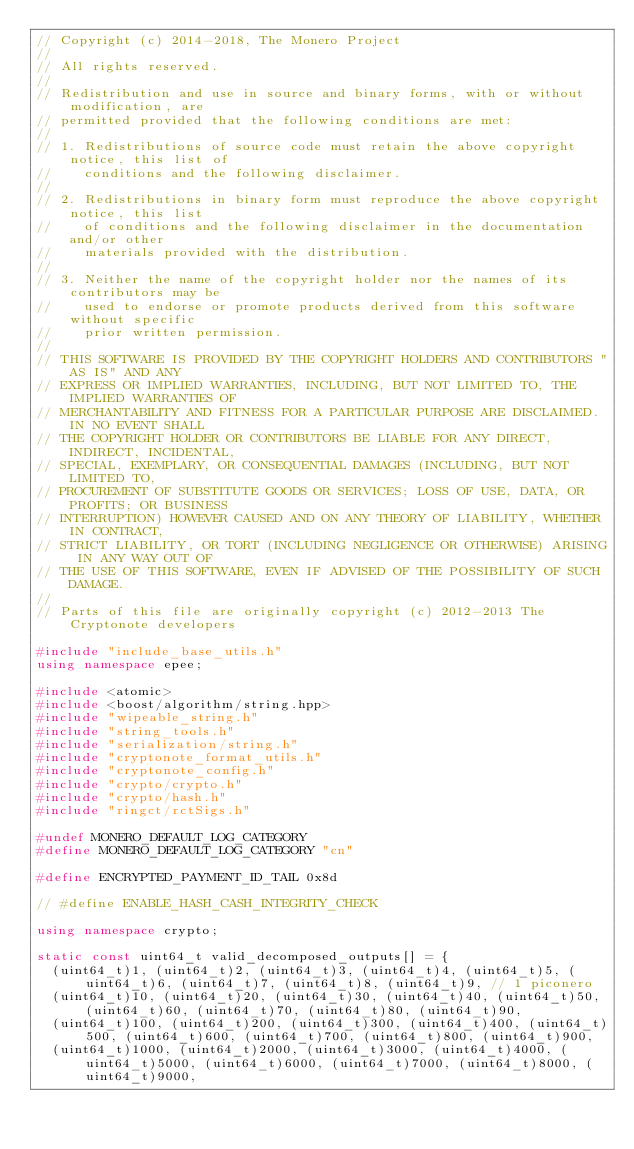<code> <loc_0><loc_0><loc_500><loc_500><_C++_>// Copyright (c) 2014-2018, The Monero Project
//
// All rights reserved.
//
// Redistribution and use in source and binary forms, with or without modification, are
// permitted provided that the following conditions are met:
//
// 1. Redistributions of source code must retain the above copyright notice, this list of
//    conditions and the following disclaimer.
//
// 2. Redistributions in binary form must reproduce the above copyright notice, this list
//    of conditions and the following disclaimer in the documentation and/or other
//    materials provided with the distribution.
//
// 3. Neither the name of the copyright holder nor the names of its contributors may be
//    used to endorse or promote products derived from this software without specific
//    prior written permission.
//
// THIS SOFTWARE IS PROVIDED BY THE COPYRIGHT HOLDERS AND CONTRIBUTORS "AS IS" AND ANY
// EXPRESS OR IMPLIED WARRANTIES, INCLUDING, BUT NOT LIMITED TO, THE IMPLIED WARRANTIES OF
// MERCHANTABILITY AND FITNESS FOR A PARTICULAR PURPOSE ARE DISCLAIMED. IN NO EVENT SHALL
// THE COPYRIGHT HOLDER OR CONTRIBUTORS BE LIABLE FOR ANY DIRECT, INDIRECT, INCIDENTAL,
// SPECIAL, EXEMPLARY, OR CONSEQUENTIAL DAMAGES (INCLUDING, BUT NOT LIMITED TO,
// PROCUREMENT OF SUBSTITUTE GOODS OR SERVICES; LOSS OF USE, DATA, OR PROFITS; OR BUSINESS
// INTERRUPTION) HOWEVER CAUSED AND ON ANY THEORY OF LIABILITY, WHETHER IN CONTRACT,
// STRICT LIABILITY, OR TORT (INCLUDING NEGLIGENCE OR OTHERWISE) ARISING IN ANY WAY OUT OF
// THE USE OF THIS SOFTWARE, EVEN IF ADVISED OF THE POSSIBILITY OF SUCH DAMAGE.
//
// Parts of this file are originally copyright (c) 2012-2013 The Cryptonote developers

#include "include_base_utils.h"
using namespace epee;

#include <atomic>
#include <boost/algorithm/string.hpp>
#include "wipeable_string.h"
#include "string_tools.h"
#include "serialization/string.h"
#include "cryptonote_format_utils.h"
#include "cryptonote_config.h"
#include "crypto/crypto.h"
#include "crypto/hash.h"
#include "ringct/rctSigs.h"

#undef MONERO_DEFAULT_LOG_CATEGORY
#define MONERO_DEFAULT_LOG_CATEGORY "cn"

#define ENCRYPTED_PAYMENT_ID_TAIL 0x8d

// #define ENABLE_HASH_CASH_INTEGRITY_CHECK

using namespace crypto;

static const uint64_t valid_decomposed_outputs[] = {
  (uint64_t)1, (uint64_t)2, (uint64_t)3, (uint64_t)4, (uint64_t)5, (uint64_t)6, (uint64_t)7, (uint64_t)8, (uint64_t)9, // 1 piconero
  (uint64_t)10, (uint64_t)20, (uint64_t)30, (uint64_t)40, (uint64_t)50, (uint64_t)60, (uint64_t)70, (uint64_t)80, (uint64_t)90,
  (uint64_t)100, (uint64_t)200, (uint64_t)300, (uint64_t)400, (uint64_t)500, (uint64_t)600, (uint64_t)700, (uint64_t)800, (uint64_t)900,
  (uint64_t)1000, (uint64_t)2000, (uint64_t)3000, (uint64_t)4000, (uint64_t)5000, (uint64_t)6000, (uint64_t)7000, (uint64_t)8000, (uint64_t)9000,</code> 